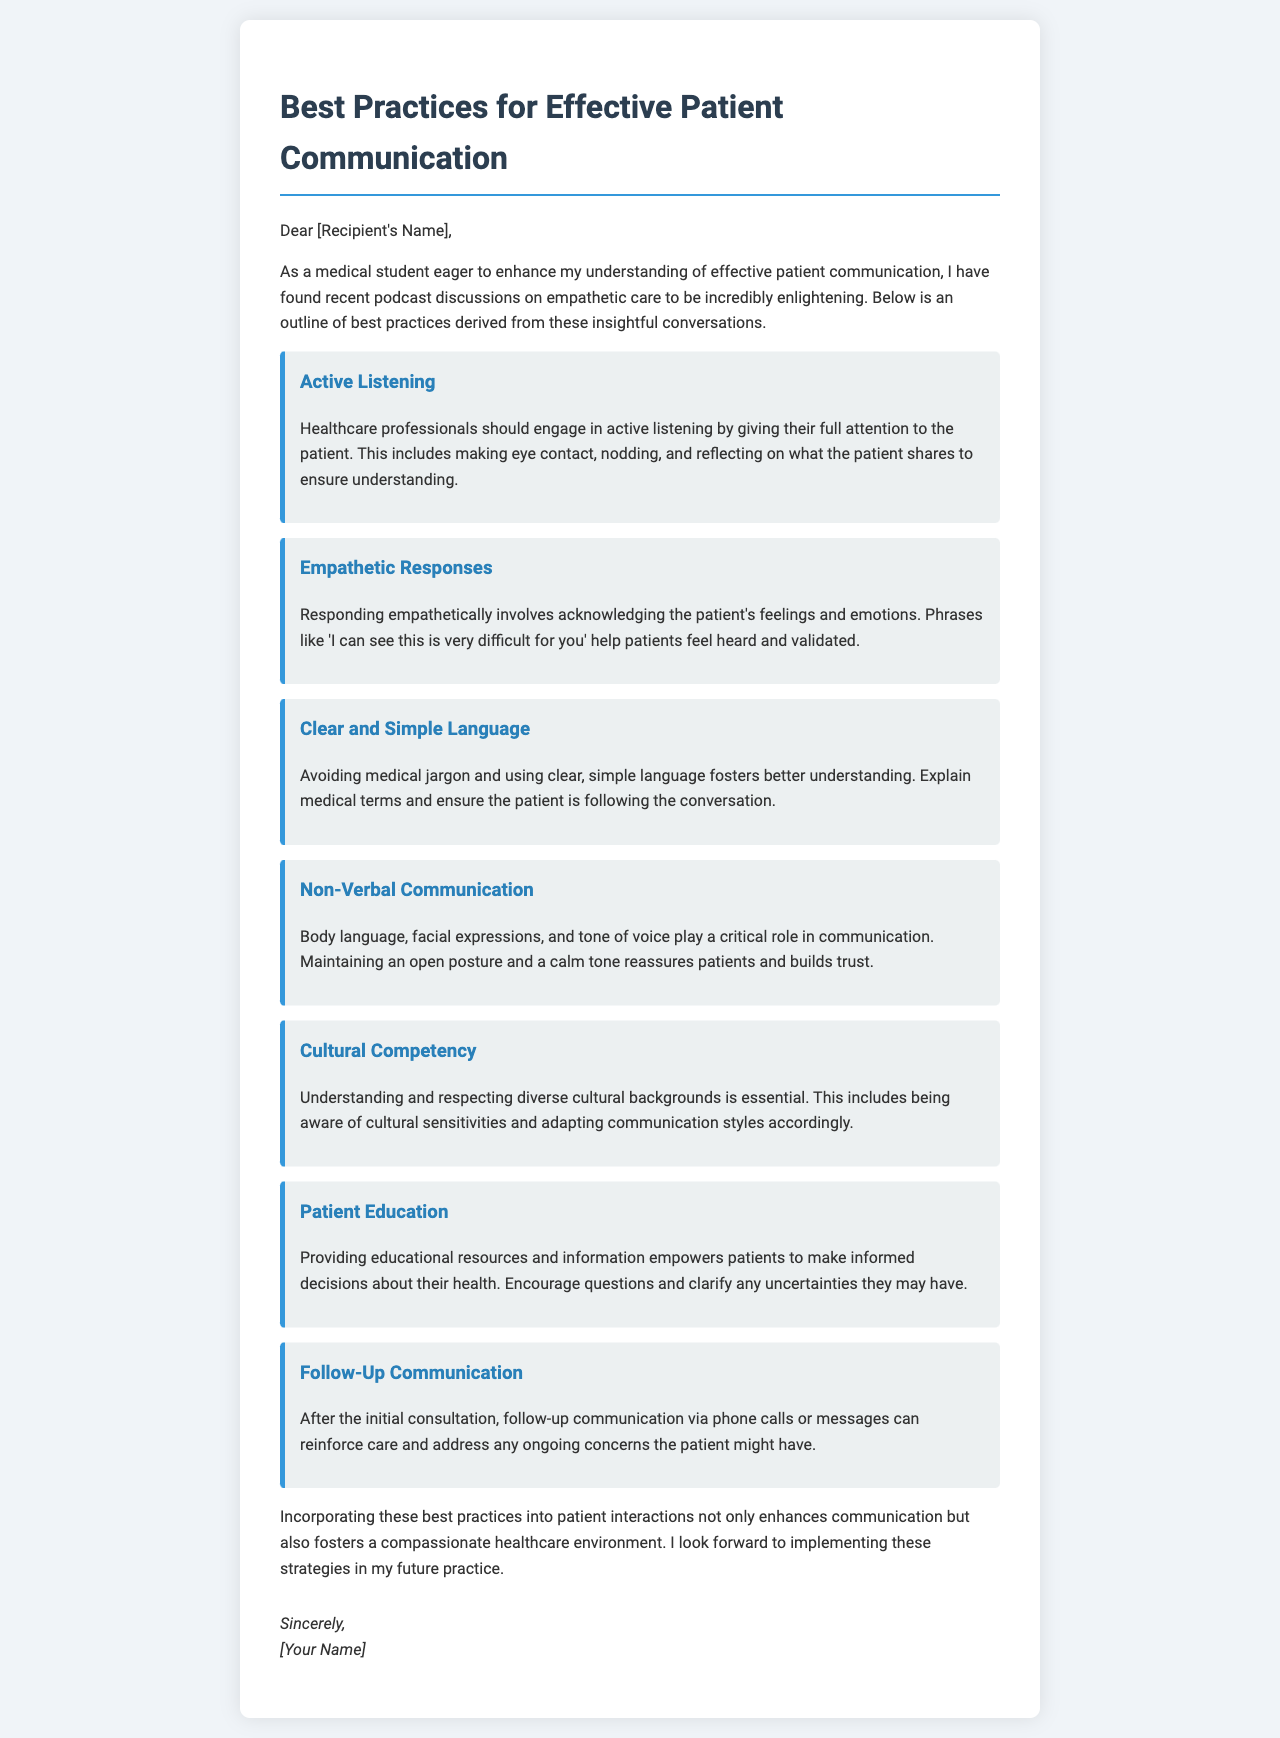What is the title of the document? The title is prominently displayed at the top of the letter, summarizing the content covered.
Answer: Best Practices for Effective Patient Communication Who is the intended recipient of the letter? The letter addresses a specific individual, which is indicated in the salutation.
Answer: [Recipient's Name] What is the first best practice mentioned? The document lists various best practices in a specific order, starting with the first mentioned practice.
Answer: Active Listening How many best practices are outlined in total? The document enumerates each practice distinctively, which allows easy counting of the listed items.
Answer: Seven What phrase is suggested for responding empathetically? The document details specific phrases that can be used to acknowledge patients' feelings, highlighting this particular one as an example.
Answer: I can see this is very difficult for you What is emphasized as critical in non-verbal communication? The text identifies specific elements of non-verbal communication that are essential for effective patient interaction.
Answer: Body language What is one way mentioned to empower patients? The document provides specific strategies that equip patients with more knowledge and understanding regarding their health.
Answer: Providing educational resources What should follow the initial consultation according to the letter? The document suggests a method to continue communication after the first meeting to ensure ongoing support for patients.
Answer: Follow-Up Communication 